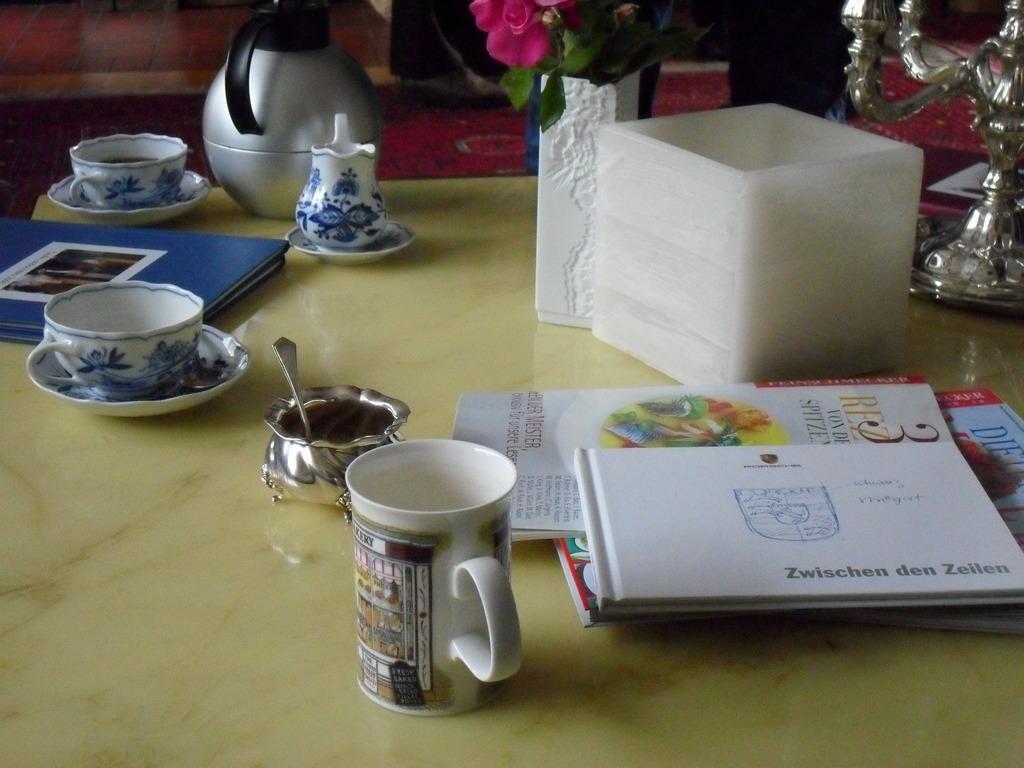In one or two sentences, can you explain what this image depicts? In this picture we can see table and on table we have cup, saucer, book, kettle, vase with flower in it, papers, box, spoon. 